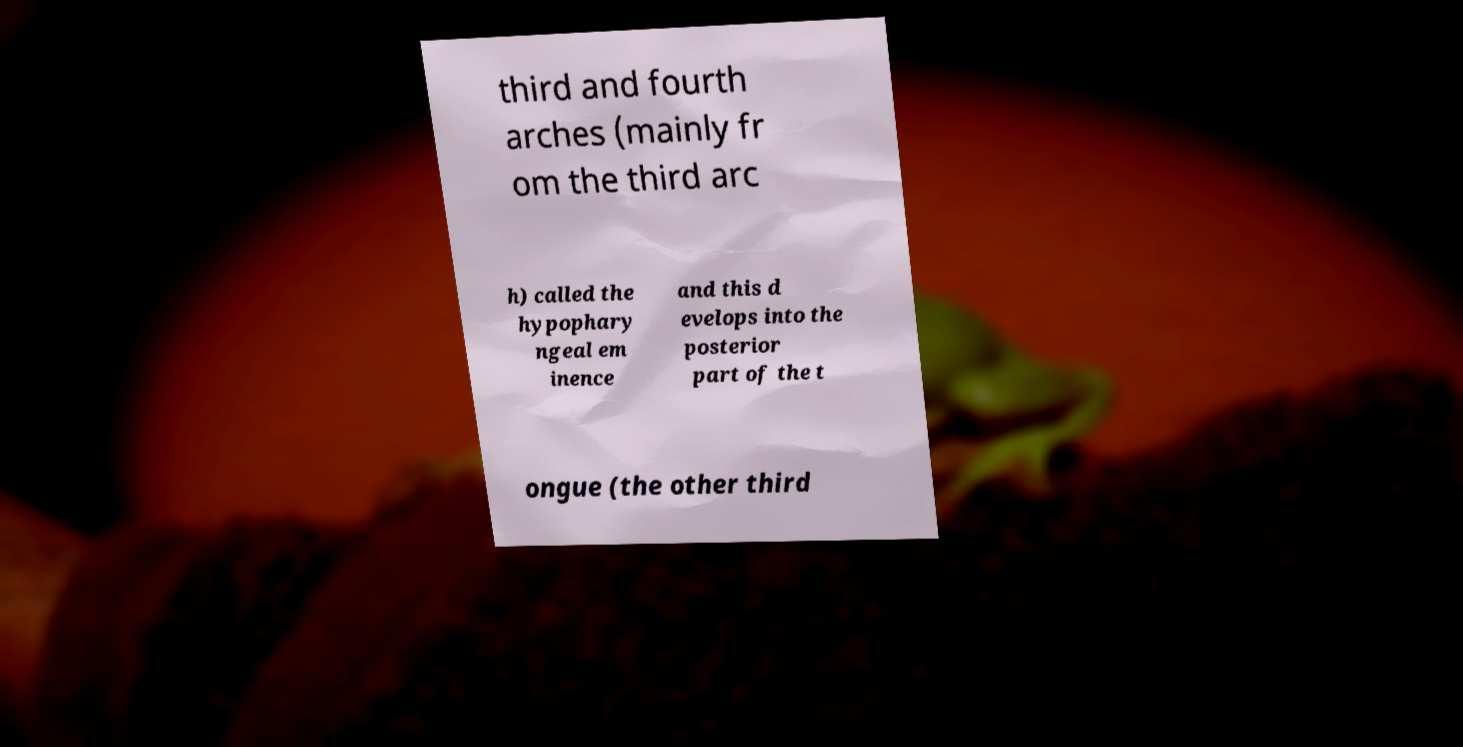Can you read and provide the text displayed in the image?This photo seems to have some interesting text. Can you extract and type it out for me? third and fourth arches (mainly fr om the third arc h) called the hypophary ngeal em inence and this d evelops into the posterior part of the t ongue (the other third 